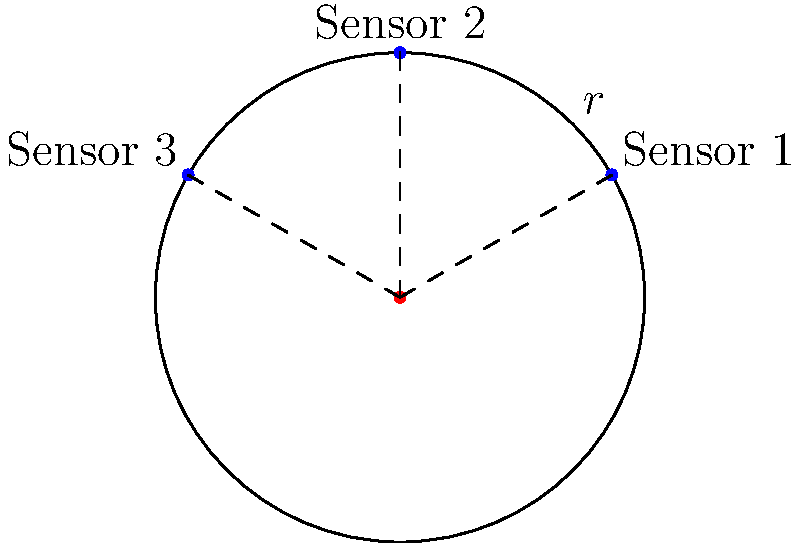In a circular production area with radius $r=5$ meters, three sensors need to be placed equidistantly along the circumference for optimal coverage. If the first sensor is placed at $\theta = \frac{\pi}{6}$ radians, what are the polar coordinates $(r, \theta)$ for all three sensors? To solve this problem, we'll follow these steps:

1) We know that the sensors need to be placed equidistantly along the circumference. This means they should be $\frac{2\pi}{3}$ radians apart (as there are $2\pi$ radians in a full circle, and we're dividing it into 3 equal parts).

2) Given information:
   - Radius $r = 5$ meters
   - First sensor is at $\theta_1 = \frac{\pi}{6}$ radians

3) Calculate the angles for the other two sensors:
   $\theta_2 = \theta_1 + \frac{2\pi}{3} = \frac{\pi}{6} + \frac{2\pi}{3} = \frac{\pi}{2}$ radians
   $\theta_3 = \theta_2 + \frac{2\pi}{3} = \frac{\pi}{2} + \frac{2\pi}{3} = \frac{5\pi}{6}$ radians

4) Now we can express the polar coordinates for each sensor as $(r, \theta)$:
   Sensor 1: $(5, \frac{\pi}{6})$
   Sensor 2: $(5, \frac{\pi}{2})$
   Sensor 3: $(5, \frac{5\pi}{6})$

These coordinates ensure that the sensors are placed optimally for coverage in the circular production area.
Answer: $(5, \frac{\pi}{6})$, $(5, \frac{\pi}{2})$, $(5, \frac{5\pi}{6})$ 